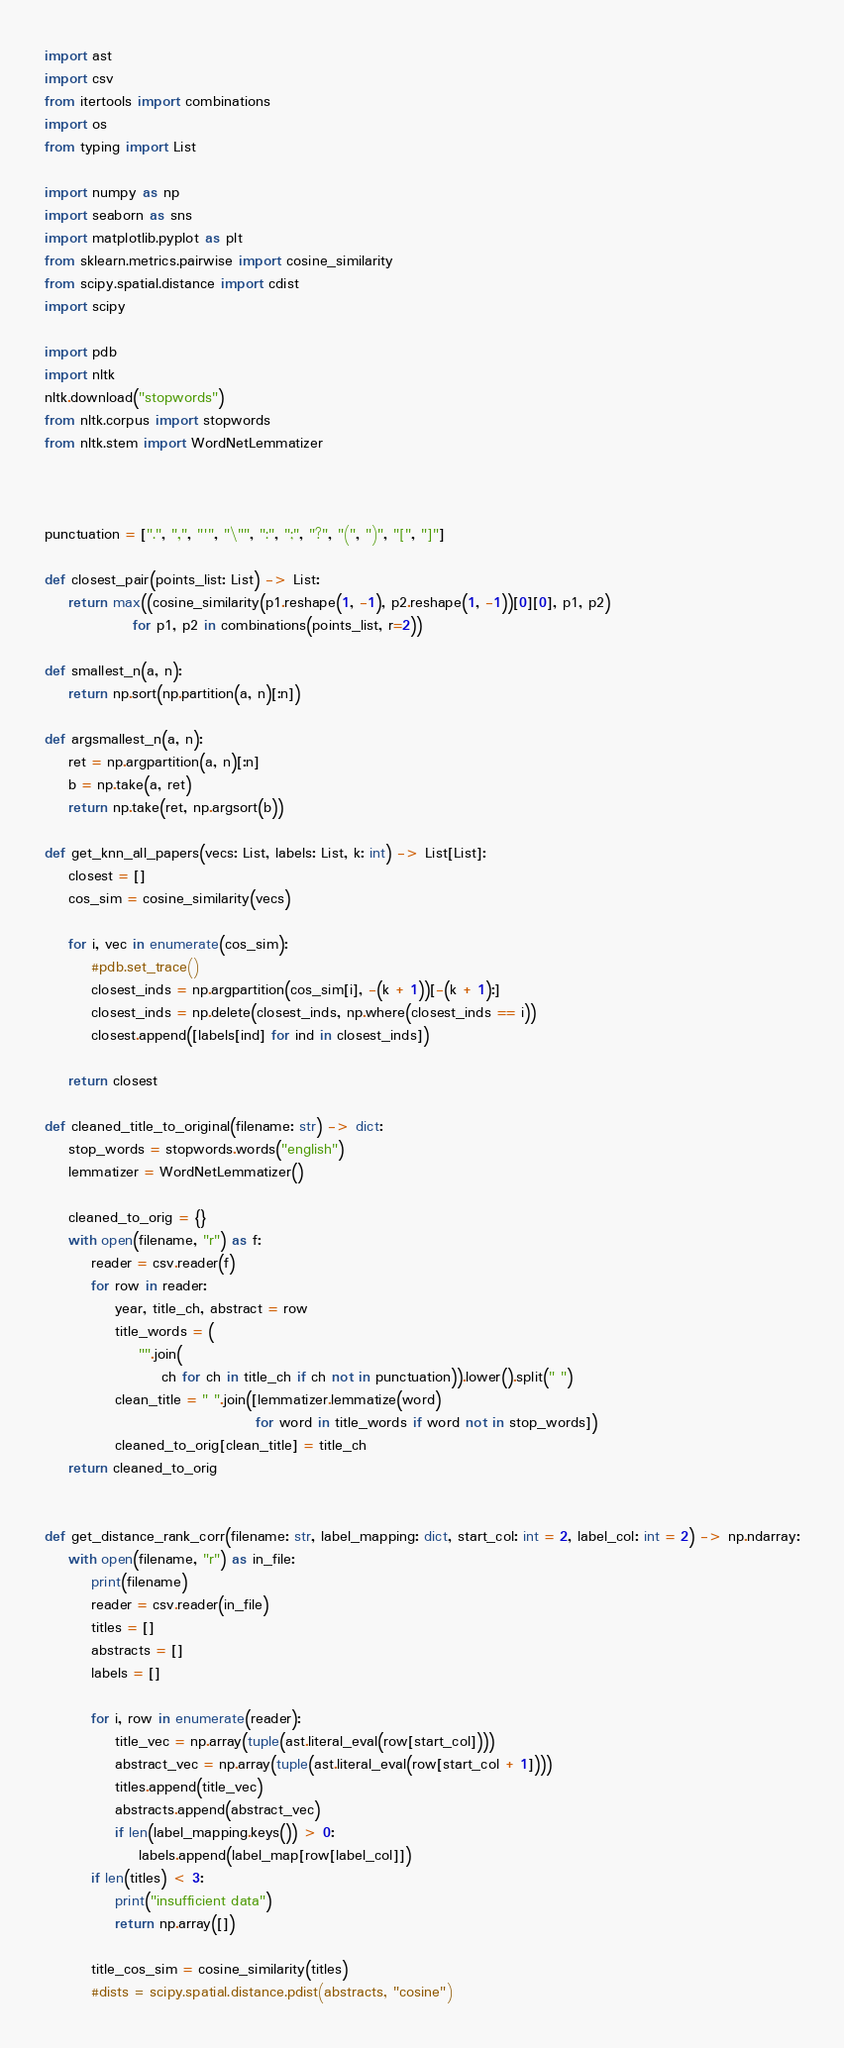<code> <loc_0><loc_0><loc_500><loc_500><_Python_>import ast
import csv
from itertools import combinations
import os
from typing import List

import numpy as np
import seaborn as sns
import matplotlib.pyplot as plt
from sklearn.metrics.pairwise import cosine_similarity
from scipy.spatial.distance import cdist
import scipy

import pdb
import nltk
nltk.download("stopwords")
from nltk.corpus import stopwords
from nltk.stem import WordNetLemmatizer



punctuation = [".", ",", "'", "\"", ":", ";", "?", "(", ")", "[", "]"]

def closest_pair(points_list: List) -> List:
    return max((cosine_similarity(p1.reshape(1, -1), p2.reshape(1, -1))[0][0], p1, p2)
               for p1, p2 in combinations(points_list, r=2))

def smallest_n(a, n):
    return np.sort(np.partition(a, n)[:n])

def argsmallest_n(a, n):
    ret = np.argpartition(a, n)[:n]
    b = np.take(a, ret)
    return np.take(ret, np.argsort(b))

def get_knn_all_papers(vecs: List, labels: List, k: int) -> List[List]:
    closest = []
    cos_sim = cosine_similarity(vecs)

    for i, vec in enumerate(cos_sim):
        #pdb.set_trace()
        closest_inds = np.argpartition(cos_sim[i], -(k + 1))[-(k + 1):]
        closest_inds = np.delete(closest_inds, np.where(closest_inds == i))
        closest.append([labels[ind] for ind in closest_inds])

    return closest

def cleaned_title_to_original(filename: str) -> dict:
    stop_words = stopwords.words("english")
    lemmatizer = WordNetLemmatizer()

    cleaned_to_orig = {}
    with open(filename, "r") as f:
        reader = csv.reader(f)
        for row in reader:
            year, title_ch, abstract = row
            title_words = (
                "".join(
                    ch for ch in title_ch if ch not in punctuation)).lower().split(" ")
            clean_title = " ".join([lemmatizer.lemmatize(word)
                                    for word in title_words if word not in stop_words])
            cleaned_to_orig[clean_title] = title_ch
    return cleaned_to_orig


def get_distance_rank_corr(filename: str, label_mapping: dict, start_col: int = 2, label_col: int = 2) -> np.ndarray:
    with open(filename, "r") as in_file:
        print(filename)
        reader = csv.reader(in_file)
        titles = []
        abstracts = []
        labels = []

        for i, row in enumerate(reader):
            title_vec = np.array(tuple(ast.literal_eval(row[start_col])))
            abstract_vec = np.array(tuple(ast.literal_eval(row[start_col + 1])))
            titles.append(title_vec)
            abstracts.append(abstract_vec)
            if len(label_mapping.keys()) > 0:
                labels.append(label_map[row[label_col]])
        if len(titles) < 3:
            print("insufficient data")
            return np.array([])

        title_cos_sim = cosine_similarity(titles)
        #dists = scipy.spatial.distance.pdist(abstracts, "cosine")</code> 